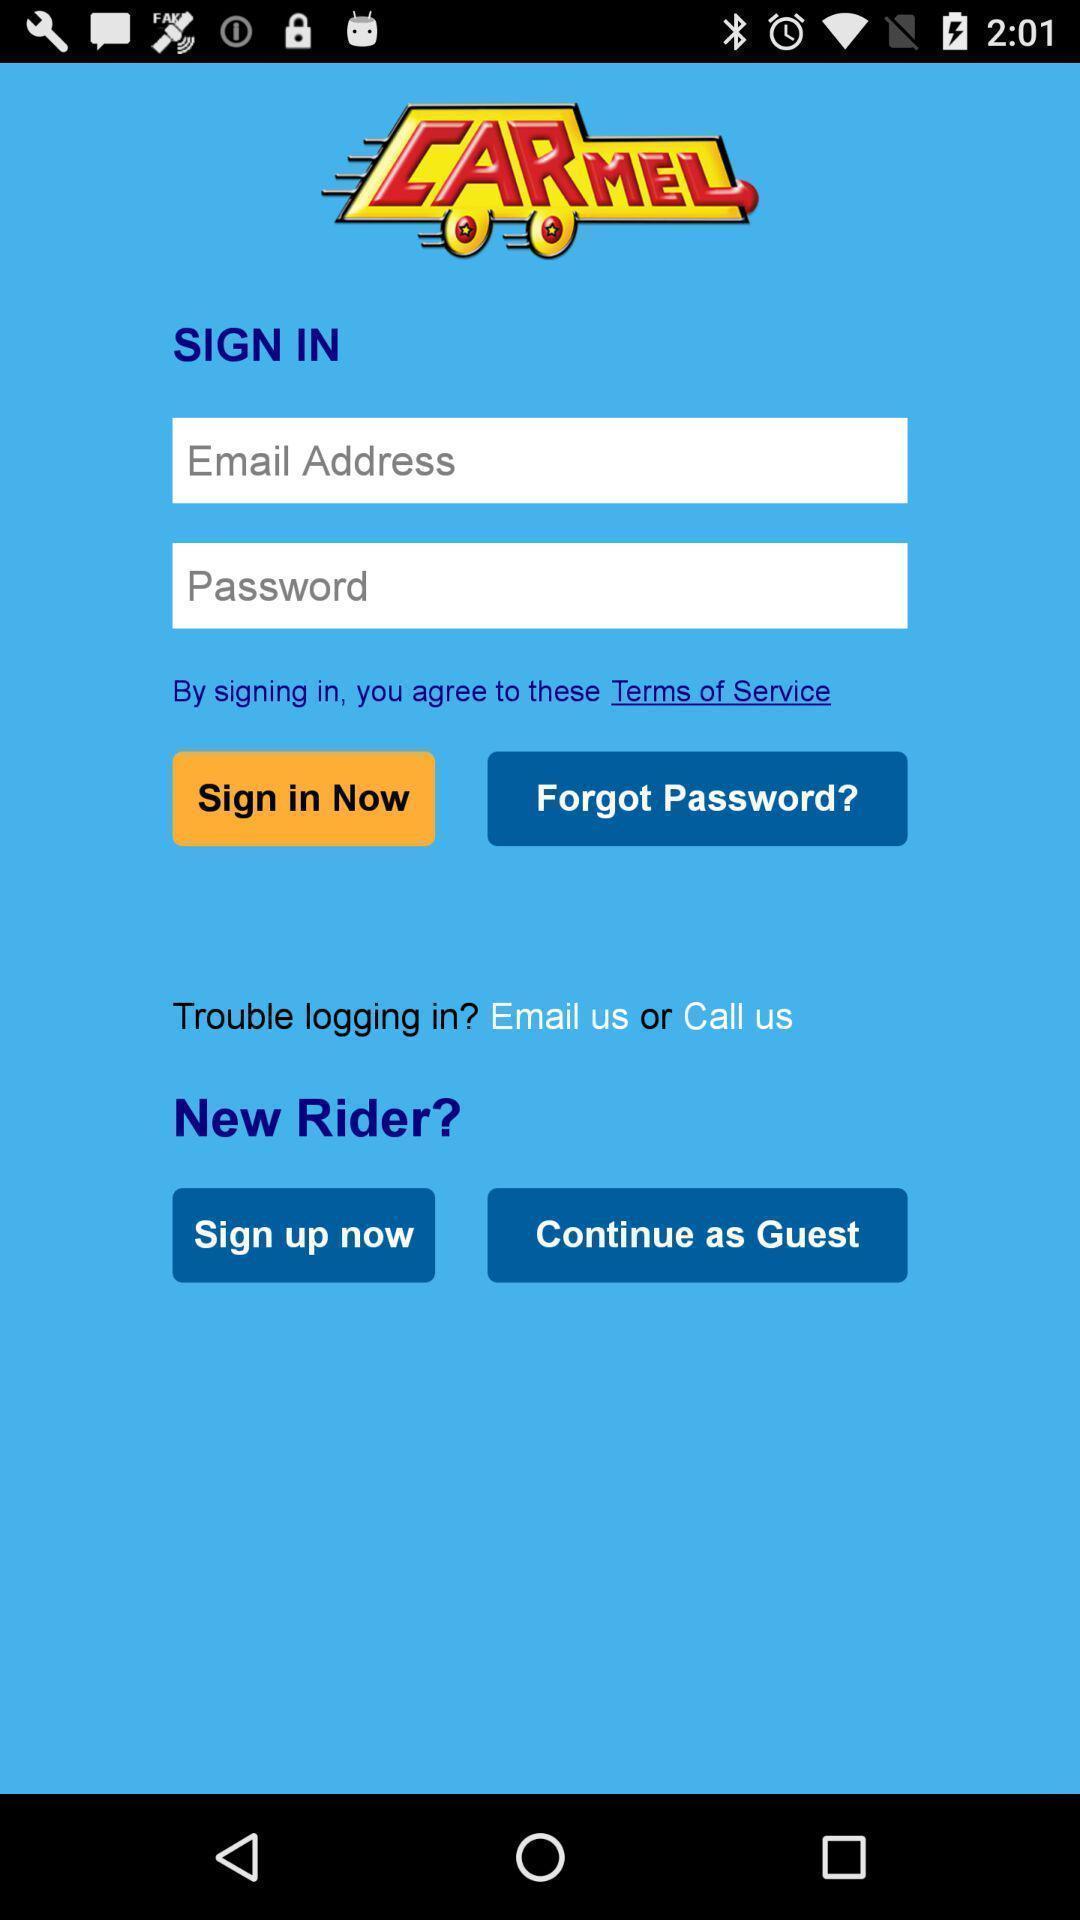What can you discern from this picture? Sign in page of travel services app. 